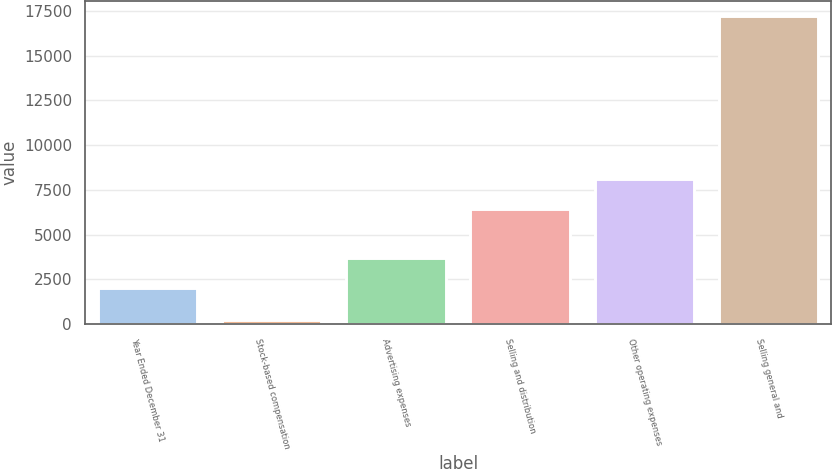<chart> <loc_0><loc_0><loc_500><loc_500><bar_chart><fcel>Year Ended December 31<fcel>Stock-based compensation<fcel>Advertising expenses<fcel>Selling and distribution<fcel>Other operating expenses<fcel>Selling general and<nl><fcel>2014<fcel>209<fcel>3714.9<fcel>6412<fcel>8112.9<fcel>17218<nl></chart> 